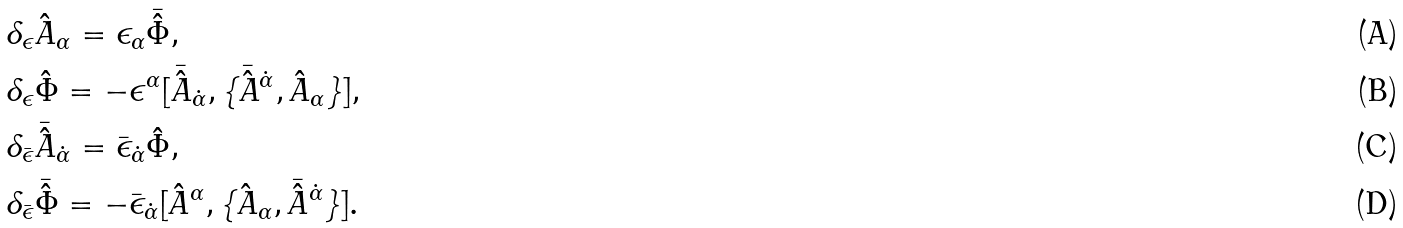Convert formula to latex. <formula><loc_0><loc_0><loc_500><loc_500>& \delta _ { \epsilon } \hat { A } _ { \alpha } = \epsilon _ { \alpha } \bar { \hat { \Phi } } , \\ & \delta _ { \epsilon } \hat { \Phi } = - \epsilon ^ { \alpha } [ \bar { \hat { A } } _ { \dot { \alpha } } , \{ \bar { \hat { A } } ^ { \dot { \alpha } } , \hat { A } _ { \alpha } \} ] , \\ & \delta _ { \bar { \epsilon } } \bar { \hat { A } } _ { \dot { \alpha } } = \bar { \epsilon } _ { \dot { \alpha } } \hat { \Phi } , \\ & \delta _ { \bar { \epsilon } } \bar { \hat { \Phi } } = - \bar { \epsilon } _ { \dot { \alpha } } [ \hat { A } ^ { \alpha } , \{ \hat { A } _ { \alpha } , \bar { \hat { A } } ^ { \dot { \alpha } } \} ] .</formula> 